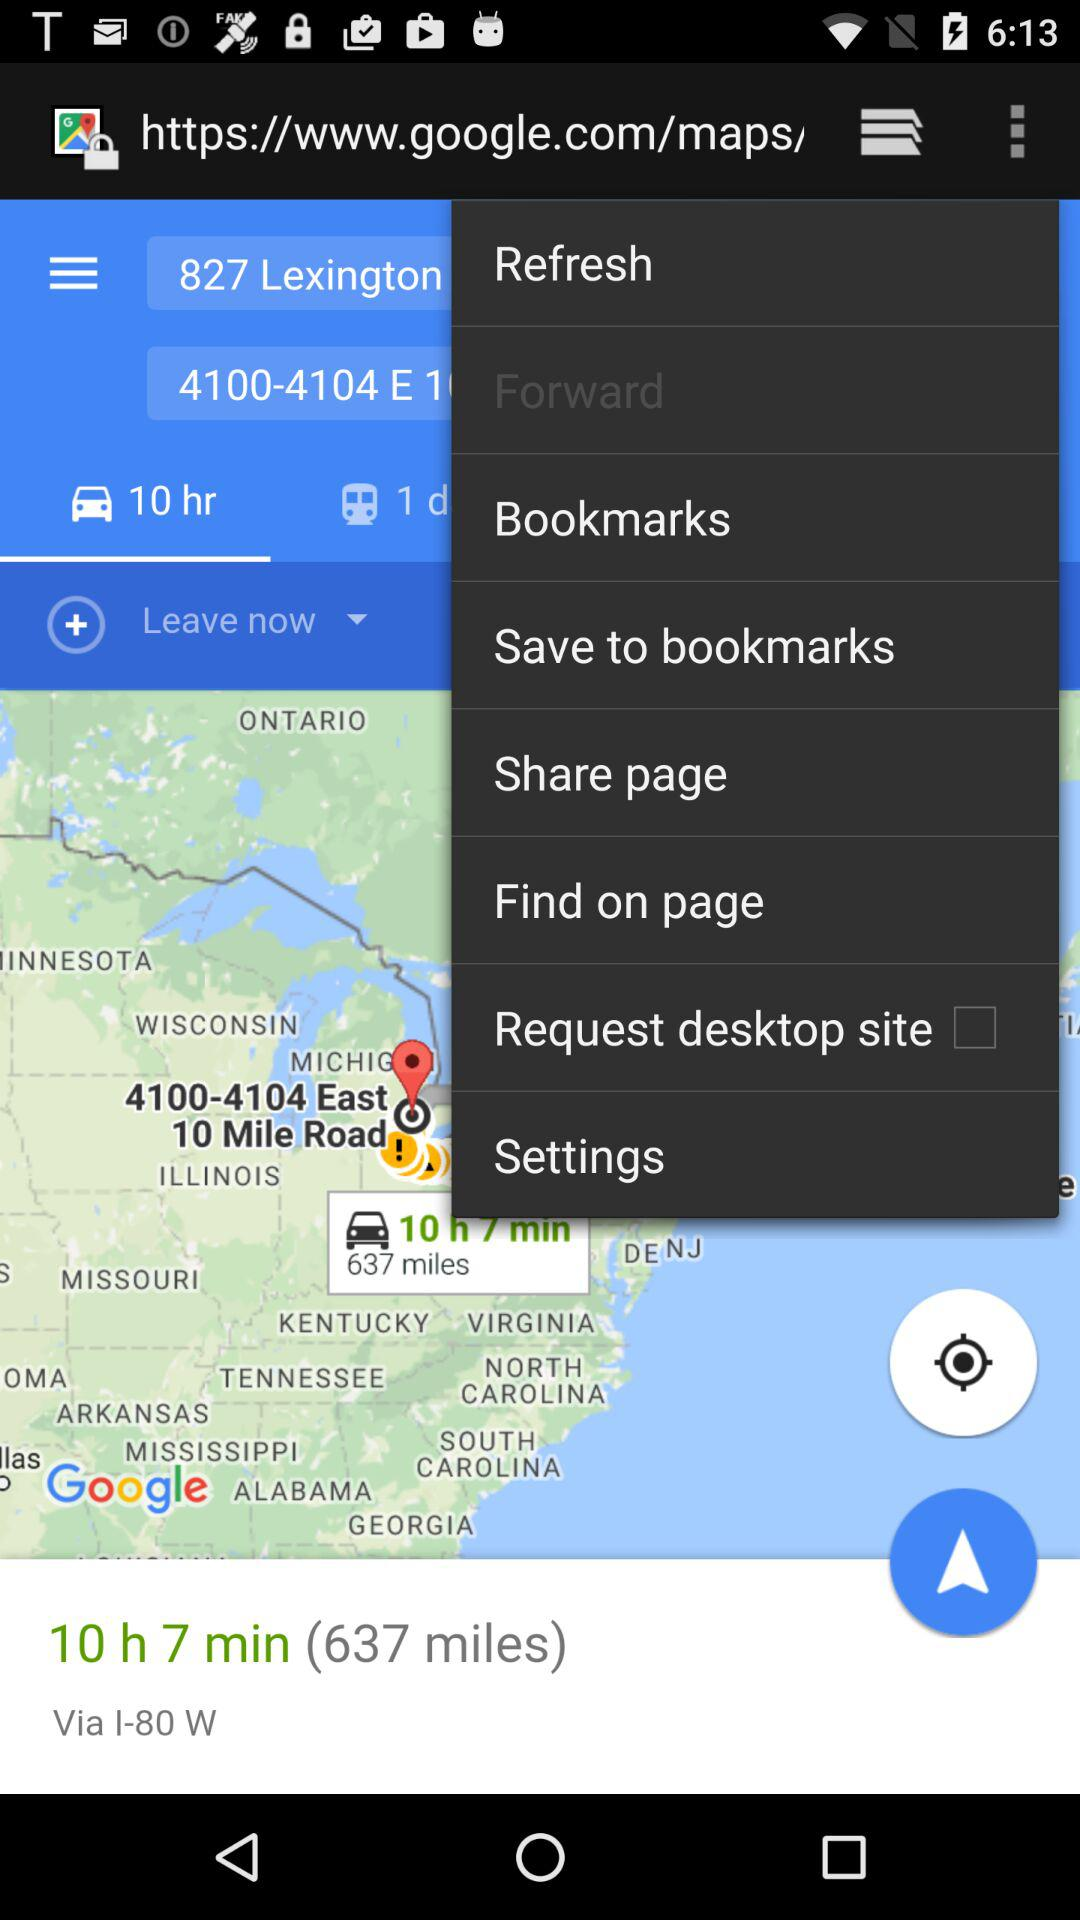Which option is selected? The selected option is "10 hr". 